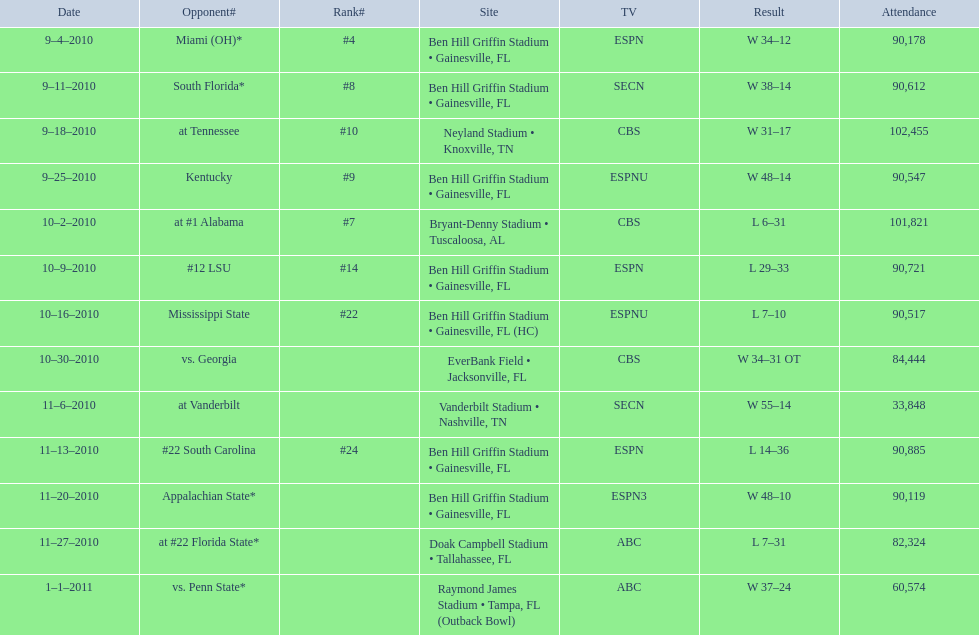The gators secured victory on september 25, 201 Gators. 